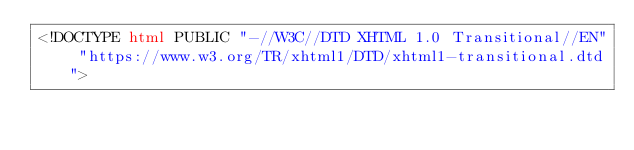<code> <loc_0><loc_0><loc_500><loc_500><_HTML_><!DOCTYPE html PUBLIC "-//W3C//DTD XHTML 1.0 Transitional//EN" "https://www.w3.org/TR/xhtml1/DTD/xhtml1-transitional.dtd"></code> 